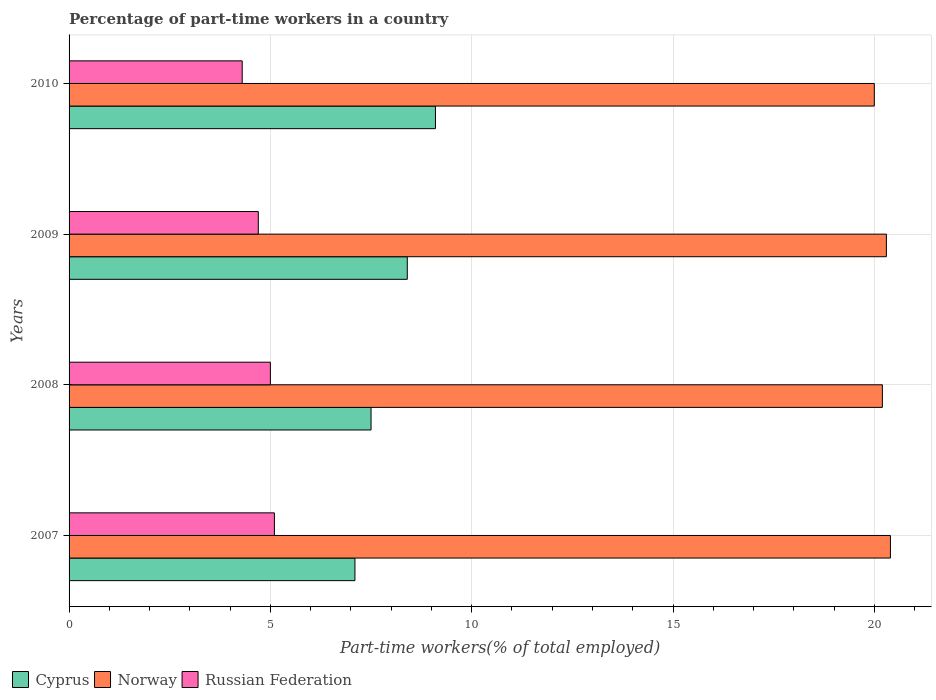How many bars are there on the 1st tick from the bottom?
Ensure brevity in your answer.  3. What is the label of the 4th group of bars from the top?
Your response must be concise. 2007. In how many cases, is the number of bars for a given year not equal to the number of legend labels?
Keep it short and to the point. 0. What is the percentage of part-time workers in Russian Federation in 2010?
Your answer should be compact. 4.3. Across all years, what is the maximum percentage of part-time workers in Norway?
Your answer should be very brief. 20.4. Across all years, what is the minimum percentage of part-time workers in Norway?
Offer a terse response. 20. In which year was the percentage of part-time workers in Norway minimum?
Provide a succinct answer. 2010. What is the total percentage of part-time workers in Cyprus in the graph?
Your response must be concise. 32.1. What is the difference between the percentage of part-time workers in Norway in 2008 and that in 2010?
Keep it short and to the point. 0.2. What is the difference between the percentage of part-time workers in Cyprus in 2010 and the percentage of part-time workers in Norway in 2008?
Keep it short and to the point. -11.1. What is the average percentage of part-time workers in Cyprus per year?
Your response must be concise. 8.02. In the year 2010, what is the difference between the percentage of part-time workers in Cyprus and percentage of part-time workers in Russian Federation?
Provide a succinct answer. 4.8. What is the ratio of the percentage of part-time workers in Russian Federation in 2008 to that in 2009?
Keep it short and to the point. 1.06. Is the difference between the percentage of part-time workers in Cyprus in 2007 and 2010 greater than the difference between the percentage of part-time workers in Russian Federation in 2007 and 2010?
Your response must be concise. No. What is the difference between the highest and the second highest percentage of part-time workers in Cyprus?
Offer a very short reply. 0.7. What is the difference between the highest and the lowest percentage of part-time workers in Cyprus?
Your response must be concise. 2. Is the sum of the percentage of part-time workers in Norway in 2007 and 2008 greater than the maximum percentage of part-time workers in Cyprus across all years?
Offer a very short reply. Yes. What does the 3rd bar from the top in 2009 represents?
Keep it short and to the point. Cyprus. What does the 3rd bar from the bottom in 2010 represents?
Provide a succinct answer. Russian Federation. How many years are there in the graph?
Provide a succinct answer. 4. What is the difference between two consecutive major ticks on the X-axis?
Your answer should be compact. 5. Does the graph contain grids?
Offer a terse response. Yes. Where does the legend appear in the graph?
Your answer should be very brief. Bottom left. What is the title of the graph?
Give a very brief answer. Percentage of part-time workers in a country. What is the label or title of the X-axis?
Offer a very short reply. Part-time workers(% of total employed). What is the Part-time workers(% of total employed) of Cyprus in 2007?
Provide a short and direct response. 7.1. What is the Part-time workers(% of total employed) in Norway in 2007?
Ensure brevity in your answer.  20.4. What is the Part-time workers(% of total employed) of Russian Federation in 2007?
Ensure brevity in your answer.  5.1. What is the Part-time workers(% of total employed) in Norway in 2008?
Ensure brevity in your answer.  20.2. What is the Part-time workers(% of total employed) of Cyprus in 2009?
Offer a very short reply. 8.4. What is the Part-time workers(% of total employed) in Norway in 2009?
Ensure brevity in your answer.  20.3. What is the Part-time workers(% of total employed) in Russian Federation in 2009?
Give a very brief answer. 4.7. What is the Part-time workers(% of total employed) in Cyprus in 2010?
Your response must be concise. 9.1. What is the Part-time workers(% of total employed) of Norway in 2010?
Keep it short and to the point. 20. What is the Part-time workers(% of total employed) in Russian Federation in 2010?
Make the answer very short. 4.3. Across all years, what is the maximum Part-time workers(% of total employed) in Cyprus?
Provide a succinct answer. 9.1. Across all years, what is the maximum Part-time workers(% of total employed) of Norway?
Your response must be concise. 20.4. Across all years, what is the maximum Part-time workers(% of total employed) in Russian Federation?
Provide a succinct answer. 5.1. Across all years, what is the minimum Part-time workers(% of total employed) of Cyprus?
Your answer should be very brief. 7.1. Across all years, what is the minimum Part-time workers(% of total employed) of Russian Federation?
Your answer should be compact. 4.3. What is the total Part-time workers(% of total employed) in Cyprus in the graph?
Give a very brief answer. 32.1. What is the total Part-time workers(% of total employed) in Norway in the graph?
Give a very brief answer. 80.9. What is the total Part-time workers(% of total employed) of Russian Federation in the graph?
Ensure brevity in your answer.  19.1. What is the difference between the Part-time workers(% of total employed) in Cyprus in 2007 and that in 2008?
Your answer should be compact. -0.4. What is the difference between the Part-time workers(% of total employed) in Cyprus in 2007 and that in 2009?
Your answer should be very brief. -1.3. What is the difference between the Part-time workers(% of total employed) in Norway in 2007 and that in 2009?
Make the answer very short. 0.1. What is the difference between the Part-time workers(% of total employed) of Russian Federation in 2007 and that in 2009?
Provide a succinct answer. 0.4. What is the difference between the Part-time workers(% of total employed) of Cyprus in 2007 and that in 2010?
Offer a terse response. -2. What is the difference between the Part-time workers(% of total employed) in Cyprus in 2008 and that in 2009?
Offer a very short reply. -0.9. What is the difference between the Part-time workers(% of total employed) in Russian Federation in 2008 and that in 2009?
Your answer should be very brief. 0.3. What is the difference between the Part-time workers(% of total employed) in Norway in 2008 and that in 2010?
Provide a short and direct response. 0.2. What is the difference between the Part-time workers(% of total employed) of Cyprus in 2009 and that in 2010?
Ensure brevity in your answer.  -0.7. What is the difference between the Part-time workers(% of total employed) of Cyprus in 2007 and the Part-time workers(% of total employed) of Norway in 2008?
Your answer should be very brief. -13.1. What is the difference between the Part-time workers(% of total employed) of Norway in 2007 and the Part-time workers(% of total employed) of Russian Federation in 2008?
Your answer should be very brief. 15.4. What is the difference between the Part-time workers(% of total employed) of Cyprus in 2007 and the Part-time workers(% of total employed) of Russian Federation in 2009?
Your answer should be compact. 2.4. What is the difference between the Part-time workers(% of total employed) of Cyprus in 2007 and the Part-time workers(% of total employed) of Norway in 2010?
Provide a succinct answer. -12.9. What is the difference between the Part-time workers(% of total employed) in Cyprus in 2007 and the Part-time workers(% of total employed) in Russian Federation in 2010?
Your answer should be compact. 2.8. What is the difference between the Part-time workers(% of total employed) in Norway in 2007 and the Part-time workers(% of total employed) in Russian Federation in 2010?
Make the answer very short. 16.1. What is the difference between the Part-time workers(% of total employed) in Cyprus in 2008 and the Part-time workers(% of total employed) in Norway in 2009?
Make the answer very short. -12.8. What is the difference between the Part-time workers(% of total employed) of Cyprus in 2008 and the Part-time workers(% of total employed) of Russian Federation in 2009?
Give a very brief answer. 2.8. What is the difference between the Part-time workers(% of total employed) of Cyprus in 2008 and the Part-time workers(% of total employed) of Russian Federation in 2010?
Ensure brevity in your answer.  3.2. What is the average Part-time workers(% of total employed) of Cyprus per year?
Provide a short and direct response. 8.03. What is the average Part-time workers(% of total employed) in Norway per year?
Offer a terse response. 20.23. What is the average Part-time workers(% of total employed) of Russian Federation per year?
Offer a very short reply. 4.78. In the year 2007, what is the difference between the Part-time workers(% of total employed) of Cyprus and Part-time workers(% of total employed) of Norway?
Offer a terse response. -13.3. In the year 2007, what is the difference between the Part-time workers(% of total employed) of Cyprus and Part-time workers(% of total employed) of Russian Federation?
Your response must be concise. 2. In the year 2008, what is the difference between the Part-time workers(% of total employed) of Cyprus and Part-time workers(% of total employed) of Norway?
Give a very brief answer. -12.7. In the year 2008, what is the difference between the Part-time workers(% of total employed) of Cyprus and Part-time workers(% of total employed) of Russian Federation?
Provide a succinct answer. 2.5. In the year 2009, what is the difference between the Part-time workers(% of total employed) of Cyprus and Part-time workers(% of total employed) of Russian Federation?
Provide a short and direct response. 3.7. In the year 2009, what is the difference between the Part-time workers(% of total employed) of Norway and Part-time workers(% of total employed) of Russian Federation?
Offer a terse response. 15.6. In the year 2010, what is the difference between the Part-time workers(% of total employed) in Cyprus and Part-time workers(% of total employed) in Norway?
Your answer should be very brief. -10.9. In the year 2010, what is the difference between the Part-time workers(% of total employed) of Cyprus and Part-time workers(% of total employed) of Russian Federation?
Provide a short and direct response. 4.8. What is the ratio of the Part-time workers(% of total employed) of Cyprus in 2007 to that in 2008?
Your answer should be very brief. 0.95. What is the ratio of the Part-time workers(% of total employed) in Norway in 2007 to that in 2008?
Provide a succinct answer. 1.01. What is the ratio of the Part-time workers(% of total employed) in Russian Federation in 2007 to that in 2008?
Your answer should be very brief. 1.02. What is the ratio of the Part-time workers(% of total employed) of Cyprus in 2007 to that in 2009?
Make the answer very short. 0.85. What is the ratio of the Part-time workers(% of total employed) in Norway in 2007 to that in 2009?
Your response must be concise. 1. What is the ratio of the Part-time workers(% of total employed) in Russian Federation in 2007 to that in 2009?
Ensure brevity in your answer.  1.09. What is the ratio of the Part-time workers(% of total employed) in Cyprus in 2007 to that in 2010?
Provide a succinct answer. 0.78. What is the ratio of the Part-time workers(% of total employed) of Russian Federation in 2007 to that in 2010?
Provide a short and direct response. 1.19. What is the ratio of the Part-time workers(% of total employed) in Cyprus in 2008 to that in 2009?
Ensure brevity in your answer.  0.89. What is the ratio of the Part-time workers(% of total employed) in Russian Federation in 2008 to that in 2009?
Give a very brief answer. 1.06. What is the ratio of the Part-time workers(% of total employed) in Cyprus in 2008 to that in 2010?
Keep it short and to the point. 0.82. What is the ratio of the Part-time workers(% of total employed) of Russian Federation in 2008 to that in 2010?
Give a very brief answer. 1.16. What is the ratio of the Part-time workers(% of total employed) of Russian Federation in 2009 to that in 2010?
Make the answer very short. 1.09. What is the difference between the highest and the second highest Part-time workers(% of total employed) of Cyprus?
Ensure brevity in your answer.  0.7. What is the difference between the highest and the second highest Part-time workers(% of total employed) in Russian Federation?
Make the answer very short. 0.1. What is the difference between the highest and the lowest Part-time workers(% of total employed) of Norway?
Your response must be concise. 0.4. 